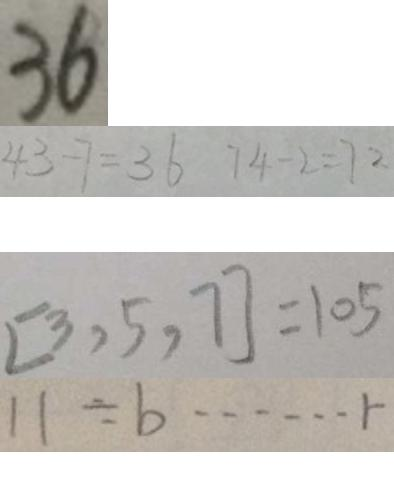Convert formula to latex. <formula><loc_0><loc_0><loc_500><loc_500>3 6 
 4 3 - 7 = 3 6 7 4 - 2 = 7 2 
 [ 3 , 5 , 7 ] = 1 0 5 
 1 1 \div b \cdots r</formula> 